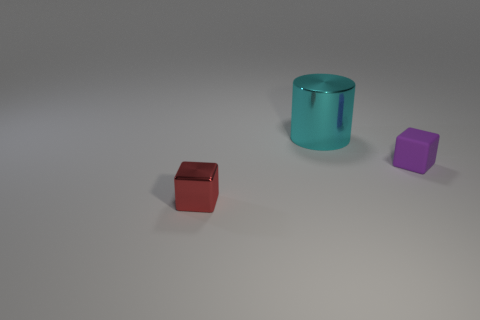Add 3 big metallic objects. How many objects exist? 6 Subtract all cylinders. How many objects are left? 2 Add 1 large yellow rubber objects. How many large yellow rubber objects exist? 1 Subtract 0 blue spheres. How many objects are left? 3 Subtract all metal cylinders. Subtract all blocks. How many objects are left? 0 Add 3 big cyan cylinders. How many big cyan cylinders are left? 4 